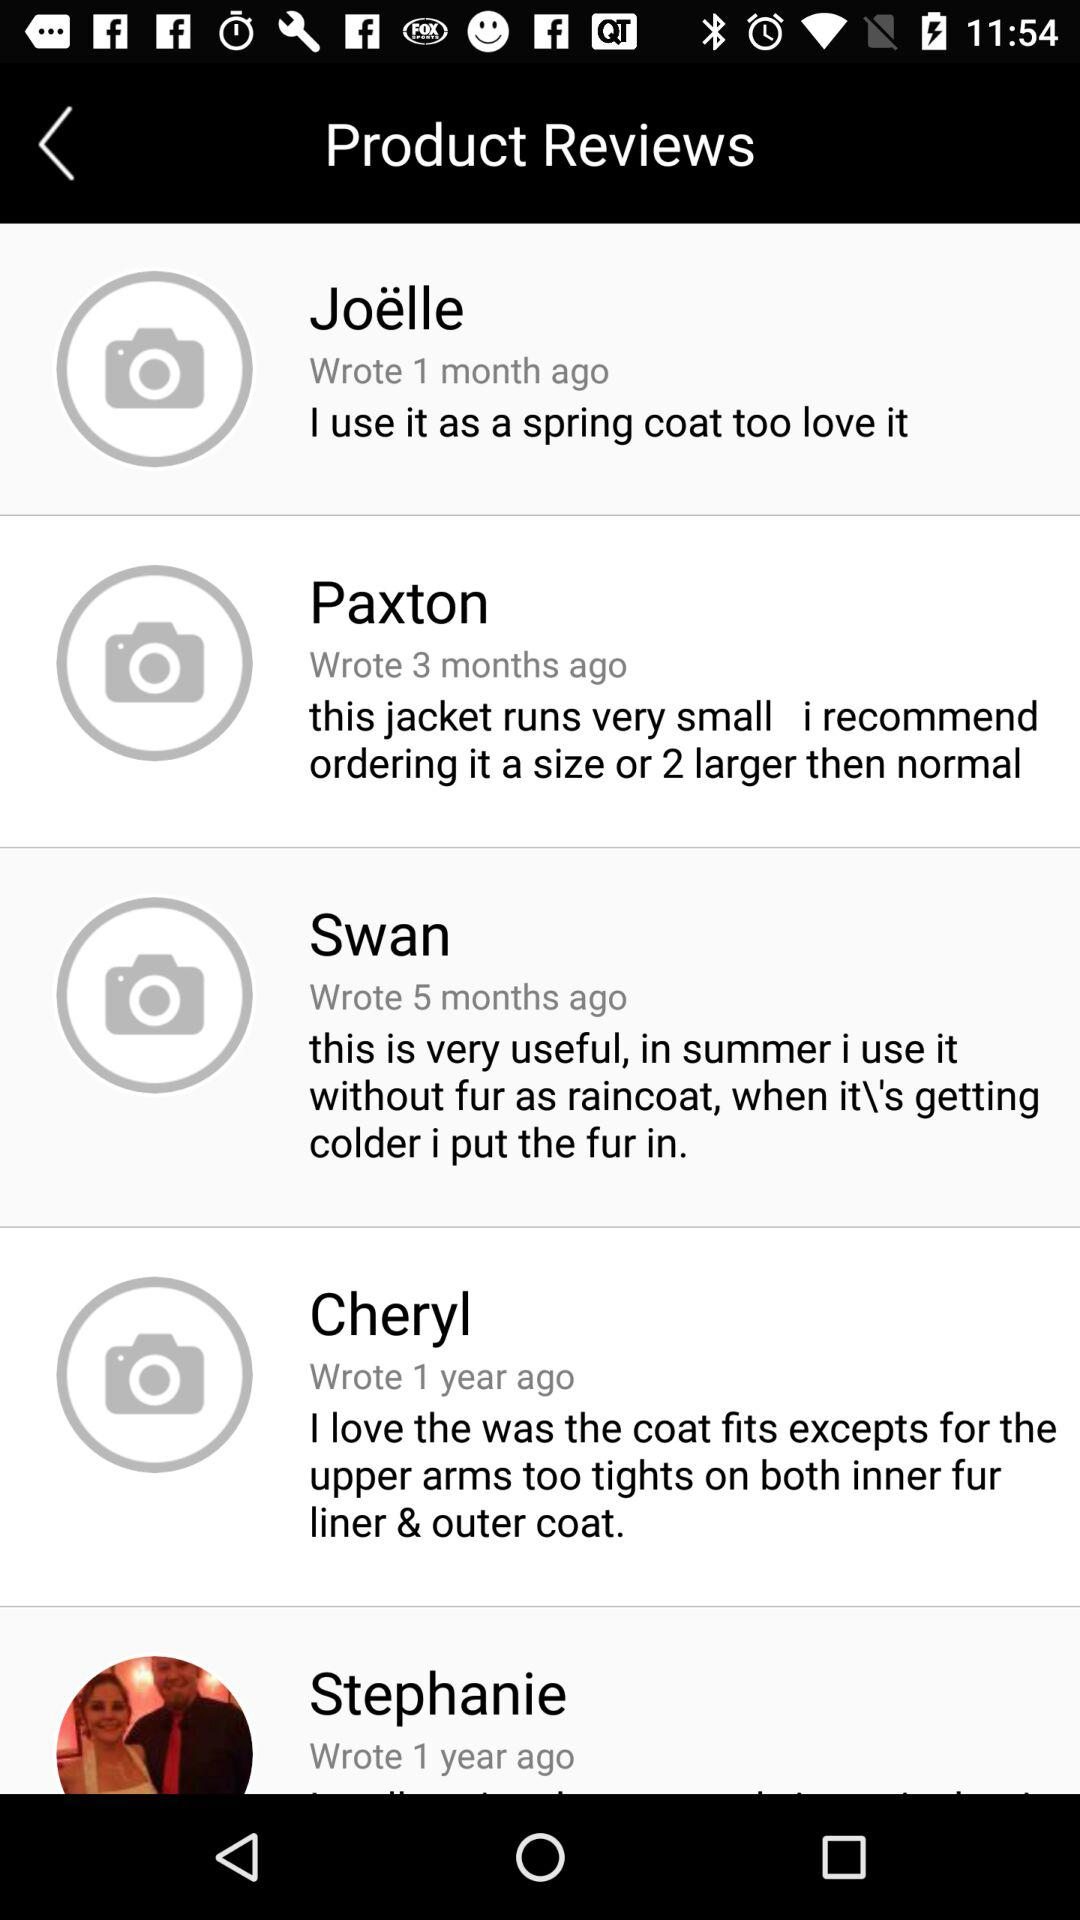Who wrote the review 1 month ago? The review was written by Joëlle. 